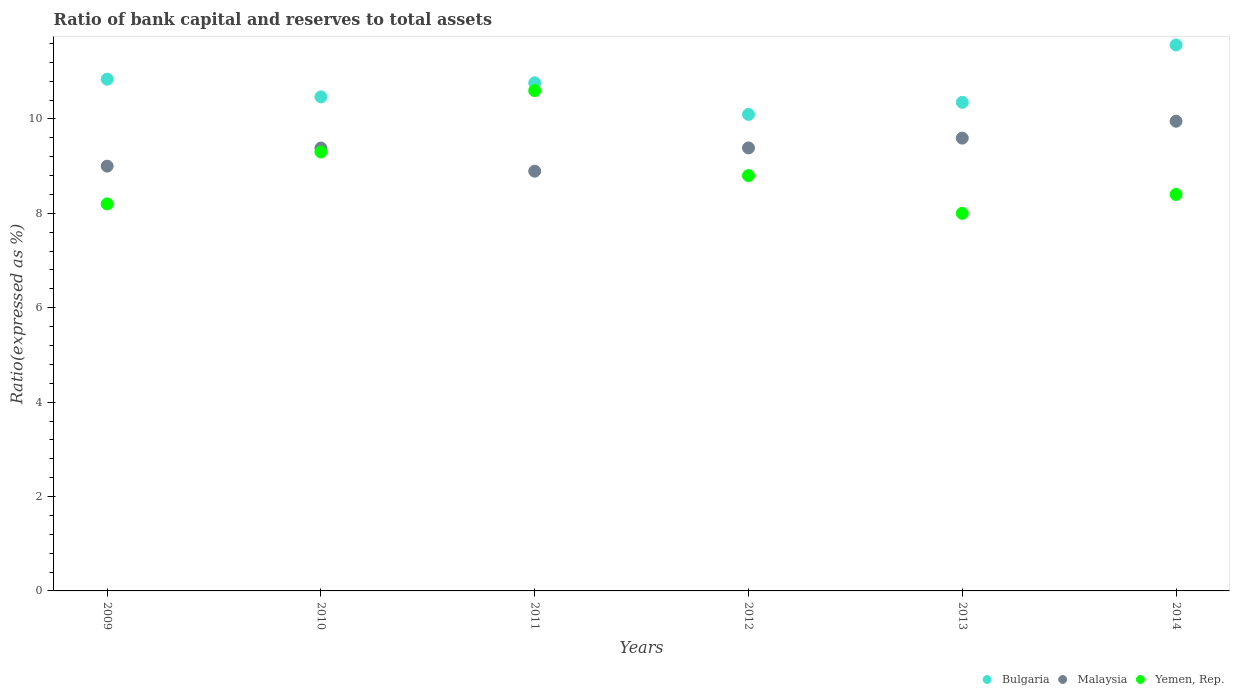What is the ratio of bank capital and reserves to total assets in Bulgaria in 2012?
Give a very brief answer. 10.1. Across all years, what is the maximum ratio of bank capital and reserves to total assets in Bulgaria?
Keep it short and to the point. 11.57. In which year was the ratio of bank capital and reserves to total assets in Yemen, Rep. maximum?
Offer a very short reply. 2011. What is the total ratio of bank capital and reserves to total assets in Bulgaria in the graph?
Provide a succinct answer. 64.09. What is the difference between the ratio of bank capital and reserves to total assets in Yemen, Rep. in 2011 and that in 2013?
Your answer should be compact. 2.6. What is the difference between the ratio of bank capital and reserves to total assets in Bulgaria in 2009 and the ratio of bank capital and reserves to total assets in Yemen, Rep. in 2012?
Provide a short and direct response. 2.04. What is the average ratio of bank capital and reserves to total assets in Malaysia per year?
Make the answer very short. 9.37. In the year 2009, what is the difference between the ratio of bank capital and reserves to total assets in Malaysia and ratio of bank capital and reserves to total assets in Bulgaria?
Provide a succinct answer. -1.84. Is the ratio of bank capital and reserves to total assets in Bulgaria in 2012 less than that in 2013?
Keep it short and to the point. Yes. What is the difference between the highest and the second highest ratio of bank capital and reserves to total assets in Bulgaria?
Your answer should be compact. 0.72. What is the difference between the highest and the lowest ratio of bank capital and reserves to total assets in Malaysia?
Your answer should be compact. 1.06. Is the sum of the ratio of bank capital and reserves to total assets in Yemen, Rep. in 2010 and 2011 greater than the maximum ratio of bank capital and reserves to total assets in Bulgaria across all years?
Provide a succinct answer. Yes. Is it the case that in every year, the sum of the ratio of bank capital and reserves to total assets in Bulgaria and ratio of bank capital and reserves to total assets in Yemen, Rep.  is greater than the ratio of bank capital and reserves to total assets in Malaysia?
Your answer should be compact. Yes. Does the ratio of bank capital and reserves to total assets in Yemen, Rep. monotonically increase over the years?
Your response must be concise. No. Is the ratio of bank capital and reserves to total assets in Bulgaria strictly less than the ratio of bank capital and reserves to total assets in Malaysia over the years?
Your answer should be very brief. No. How many dotlines are there?
Give a very brief answer. 3. Are the values on the major ticks of Y-axis written in scientific E-notation?
Make the answer very short. No. Does the graph contain any zero values?
Offer a terse response. No. How many legend labels are there?
Offer a terse response. 3. What is the title of the graph?
Make the answer very short. Ratio of bank capital and reserves to total assets. What is the label or title of the Y-axis?
Provide a short and direct response. Ratio(expressed as %). What is the Ratio(expressed as %) of Bulgaria in 2009?
Your answer should be compact. 10.84. What is the Ratio(expressed as %) of Yemen, Rep. in 2009?
Offer a terse response. 8.2. What is the Ratio(expressed as %) of Bulgaria in 2010?
Your answer should be very brief. 10.47. What is the Ratio(expressed as %) of Malaysia in 2010?
Make the answer very short. 9.38. What is the Ratio(expressed as %) in Yemen, Rep. in 2010?
Make the answer very short. 9.3. What is the Ratio(expressed as %) in Bulgaria in 2011?
Provide a succinct answer. 10.76. What is the Ratio(expressed as %) in Malaysia in 2011?
Make the answer very short. 8.89. What is the Ratio(expressed as %) in Yemen, Rep. in 2011?
Your answer should be compact. 10.6. What is the Ratio(expressed as %) in Bulgaria in 2012?
Offer a terse response. 10.1. What is the Ratio(expressed as %) of Malaysia in 2012?
Your answer should be very brief. 9.39. What is the Ratio(expressed as %) in Yemen, Rep. in 2012?
Offer a terse response. 8.8. What is the Ratio(expressed as %) of Bulgaria in 2013?
Ensure brevity in your answer.  10.35. What is the Ratio(expressed as %) in Malaysia in 2013?
Your answer should be compact. 9.59. What is the Ratio(expressed as %) of Yemen, Rep. in 2013?
Your response must be concise. 8. What is the Ratio(expressed as %) of Bulgaria in 2014?
Provide a succinct answer. 11.57. What is the Ratio(expressed as %) of Malaysia in 2014?
Give a very brief answer. 9.95. What is the Ratio(expressed as %) of Yemen, Rep. in 2014?
Give a very brief answer. 8.4. Across all years, what is the maximum Ratio(expressed as %) of Bulgaria?
Ensure brevity in your answer.  11.57. Across all years, what is the maximum Ratio(expressed as %) of Malaysia?
Offer a terse response. 9.95. Across all years, what is the minimum Ratio(expressed as %) in Bulgaria?
Keep it short and to the point. 10.1. Across all years, what is the minimum Ratio(expressed as %) of Malaysia?
Provide a succinct answer. 8.89. What is the total Ratio(expressed as %) in Bulgaria in the graph?
Provide a short and direct response. 64.09. What is the total Ratio(expressed as %) in Malaysia in the graph?
Your answer should be very brief. 56.21. What is the total Ratio(expressed as %) in Yemen, Rep. in the graph?
Provide a short and direct response. 53.3. What is the difference between the Ratio(expressed as %) in Bulgaria in 2009 and that in 2010?
Your response must be concise. 0.37. What is the difference between the Ratio(expressed as %) in Malaysia in 2009 and that in 2010?
Provide a succinct answer. -0.38. What is the difference between the Ratio(expressed as %) in Yemen, Rep. in 2009 and that in 2010?
Keep it short and to the point. -1.1. What is the difference between the Ratio(expressed as %) in Bulgaria in 2009 and that in 2011?
Offer a very short reply. 0.08. What is the difference between the Ratio(expressed as %) in Malaysia in 2009 and that in 2011?
Your response must be concise. 0.11. What is the difference between the Ratio(expressed as %) in Yemen, Rep. in 2009 and that in 2011?
Offer a very short reply. -2.4. What is the difference between the Ratio(expressed as %) of Bulgaria in 2009 and that in 2012?
Make the answer very short. 0.75. What is the difference between the Ratio(expressed as %) in Malaysia in 2009 and that in 2012?
Provide a succinct answer. -0.39. What is the difference between the Ratio(expressed as %) in Bulgaria in 2009 and that in 2013?
Give a very brief answer. 0.49. What is the difference between the Ratio(expressed as %) of Malaysia in 2009 and that in 2013?
Your response must be concise. -0.59. What is the difference between the Ratio(expressed as %) in Bulgaria in 2009 and that in 2014?
Your response must be concise. -0.72. What is the difference between the Ratio(expressed as %) in Malaysia in 2009 and that in 2014?
Provide a succinct answer. -0.95. What is the difference between the Ratio(expressed as %) of Yemen, Rep. in 2009 and that in 2014?
Provide a succinct answer. -0.2. What is the difference between the Ratio(expressed as %) of Bulgaria in 2010 and that in 2011?
Keep it short and to the point. -0.3. What is the difference between the Ratio(expressed as %) in Malaysia in 2010 and that in 2011?
Your response must be concise. 0.49. What is the difference between the Ratio(expressed as %) in Yemen, Rep. in 2010 and that in 2011?
Offer a terse response. -1.3. What is the difference between the Ratio(expressed as %) in Bulgaria in 2010 and that in 2012?
Your response must be concise. 0.37. What is the difference between the Ratio(expressed as %) in Malaysia in 2010 and that in 2012?
Your response must be concise. -0. What is the difference between the Ratio(expressed as %) in Bulgaria in 2010 and that in 2013?
Your answer should be very brief. 0.12. What is the difference between the Ratio(expressed as %) in Malaysia in 2010 and that in 2013?
Give a very brief answer. -0.21. What is the difference between the Ratio(expressed as %) in Yemen, Rep. in 2010 and that in 2013?
Your answer should be compact. 1.3. What is the difference between the Ratio(expressed as %) of Bulgaria in 2010 and that in 2014?
Ensure brevity in your answer.  -1.1. What is the difference between the Ratio(expressed as %) of Malaysia in 2010 and that in 2014?
Make the answer very short. -0.57. What is the difference between the Ratio(expressed as %) of Bulgaria in 2011 and that in 2012?
Provide a short and direct response. 0.67. What is the difference between the Ratio(expressed as %) of Malaysia in 2011 and that in 2012?
Provide a short and direct response. -0.49. What is the difference between the Ratio(expressed as %) in Yemen, Rep. in 2011 and that in 2012?
Your answer should be compact. 1.8. What is the difference between the Ratio(expressed as %) in Bulgaria in 2011 and that in 2013?
Ensure brevity in your answer.  0.41. What is the difference between the Ratio(expressed as %) in Malaysia in 2011 and that in 2013?
Offer a terse response. -0.7. What is the difference between the Ratio(expressed as %) of Yemen, Rep. in 2011 and that in 2013?
Keep it short and to the point. 2.6. What is the difference between the Ratio(expressed as %) of Bulgaria in 2011 and that in 2014?
Offer a very short reply. -0.8. What is the difference between the Ratio(expressed as %) in Malaysia in 2011 and that in 2014?
Keep it short and to the point. -1.06. What is the difference between the Ratio(expressed as %) in Yemen, Rep. in 2011 and that in 2014?
Provide a short and direct response. 2.2. What is the difference between the Ratio(expressed as %) of Bulgaria in 2012 and that in 2013?
Your response must be concise. -0.26. What is the difference between the Ratio(expressed as %) in Malaysia in 2012 and that in 2013?
Keep it short and to the point. -0.21. What is the difference between the Ratio(expressed as %) in Yemen, Rep. in 2012 and that in 2013?
Your response must be concise. 0.8. What is the difference between the Ratio(expressed as %) of Bulgaria in 2012 and that in 2014?
Make the answer very short. -1.47. What is the difference between the Ratio(expressed as %) of Malaysia in 2012 and that in 2014?
Offer a terse response. -0.57. What is the difference between the Ratio(expressed as %) of Bulgaria in 2013 and that in 2014?
Your response must be concise. -1.22. What is the difference between the Ratio(expressed as %) of Malaysia in 2013 and that in 2014?
Your answer should be very brief. -0.36. What is the difference between the Ratio(expressed as %) in Bulgaria in 2009 and the Ratio(expressed as %) in Malaysia in 2010?
Offer a terse response. 1.46. What is the difference between the Ratio(expressed as %) in Bulgaria in 2009 and the Ratio(expressed as %) in Yemen, Rep. in 2010?
Make the answer very short. 1.54. What is the difference between the Ratio(expressed as %) of Bulgaria in 2009 and the Ratio(expressed as %) of Malaysia in 2011?
Your answer should be very brief. 1.95. What is the difference between the Ratio(expressed as %) in Bulgaria in 2009 and the Ratio(expressed as %) in Yemen, Rep. in 2011?
Offer a very short reply. 0.24. What is the difference between the Ratio(expressed as %) in Bulgaria in 2009 and the Ratio(expressed as %) in Malaysia in 2012?
Offer a very short reply. 1.46. What is the difference between the Ratio(expressed as %) of Bulgaria in 2009 and the Ratio(expressed as %) of Yemen, Rep. in 2012?
Ensure brevity in your answer.  2.04. What is the difference between the Ratio(expressed as %) of Malaysia in 2009 and the Ratio(expressed as %) of Yemen, Rep. in 2012?
Ensure brevity in your answer.  0.2. What is the difference between the Ratio(expressed as %) of Bulgaria in 2009 and the Ratio(expressed as %) of Malaysia in 2013?
Ensure brevity in your answer.  1.25. What is the difference between the Ratio(expressed as %) in Bulgaria in 2009 and the Ratio(expressed as %) in Yemen, Rep. in 2013?
Your answer should be compact. 2.84. What is the difference between the Ratio(expressed as %) in Malaysia in 2009 and the Ratio(expressed as %) in Yemen, Rep. in 2013?
Provide a succinct answer. 1. What is the difference between the Ratio(expressed as %) of Bulgaria in 2009 and the Ratio(expressed as %) of Malaysia in 2014?
Offer a very short reply. 0.89. What is the difference between the Ratio(expressed as %) in Bulgaria in 2009 and the Ratio(expressed as %) in Yemen, Rep. in 2014?
Offer a terse response. 2.44. What is the difference between the Ratio(expressed as %) of Malaysia in 2009 and the Ratio(expressed as %) of Yemen, Rep. in 2014?
Make the answer very short. 0.6. What is the difference between the Ratio(expressed as %) of Bulgaria in 2010 and the Ratio(expressed as %) of Malaysia in 2011?
Provide a short and direct response. 1.57. What is the difference between the Ratio(expressed as %) of Bulgaria in 2010 and the Ratio(expressed as %) of Yemen, Rep. in 2011?
Your response must be concise. -0.13. What is the difference between the Ratio(expressed as %) of Malaysia in 2010 and the Ratio(expressed as %) of Yemen, Rep. in 2011?
Provide a short and direct response. -1.22. What is the difference between the Ratio(expressed as %) in Bulgaria in 2010 and the Ratio(expressed as %) in Malaysia in 2012?
Your response must be concise. 1.08. What is the difference between the Ratio(expressed as %) in Bulgaria in 2010 and the Ratio(expressed as %) in Yemen, Rep. in 2012?
Offer a terse response. 1.67. What is the difference between the Ratio(expressed as %) of Malaysia in 2010 and the Ratio(expressed as %) of Yemen, Rep. in 2012?
Offer a terse response. 0.58. What is the difference between the Ratio(expressed as %) in Bulgaria in 2010 and the Ratio(expressed as %) in Malaysia in 2013?
Your answer should be compact. 0.87. What is the difference between the Ratio(expressed as %) of Bulgaria in 2010 and the Ratio(expressed as %) of Yemen, Rep. in 2013?
Provide a short and direct response. 2.47. What is the difference between the Ratio(expressed as %) in Malaysia in 2010 and the Ratio(expressed as %) in Yemen, Rep. in 2013?
Keep it short and to the point. 1.38. What is the difference between the Ratio(expressed as %) in Bulgaria in 2010 and the Ratio(expressed as %) in Malaysia in 2014?
Make the answer very short. 0.52. What is the difference between the Ratio(expressed as %) of Bulgaria in 2010 and the Ratio(expressed as %) of Yemen, Rep. in 2014?
Provide a short and direct response. 2.07. What is the difference between the Ratio(expressed as %) in Malaysia in 2010 and the Ratio(expressed as %) in Yemen, Rep. in 2014?
Your response must be concise. 0.98. What is the difference between the Ratio(expressed as %) of Bulgaria in 2011 and the Ratio(expressed as %) of Malaysia in 2012?
Provide a succinct answer. 1.38. What is the difference between the Ratio(expressed as %) of Bulgaria in 2011 and the Ratio(expressed as %) of Yemen, Rep. in 2012?
Offer a very short reply. 1.96. What is the difference between the Ratio(expressed as %) of Malaysia in 2011 and the Ratio(expressed as %) of Yemen, Rep. in 2012?
Your answer should be very brief. 0.09. What is the difference between the Ratio(expressed as %) of Bulgaria in 2011 and the Ratio(expressed as %) of Malaysia in 2013?
Give a very brief answer. 1.17. What is the difference between the Ratio(expressed as %) of Bulgaria in 2011 and the Ratio(expressed as %) of Yemen, Rep. in 2013?
Make the answer very short. 2.76. What is the difference between the Ratio(expressed as %) in Malaysia in 2011 and the Ratio(expressed as %) in Yemen, Rep. in 2013?
Make the answer very short. 0.89. What is the difference between the Ratio(expressed as %) in Bulgaria in 2011 and the Ratio(expressed as %) in Malaysia in 2014?
Make the answer very short. 0.81. What is the difference between the Ratio(expressed as %) in Bulgaria in 2011 and the Ratio(expressed as %) in Yemen, Rep. in 2014?
Your response must be concise. 2.36. What is the difference between the Ratio(expressed as %) in Malaysia in 2011 and the Ratio(expressed as %) in Yemen, Rep. in 2014?
Provide a succinct answer. 0.49. What is the difference between the Ratio(expressed as %) in Bulgaria in 2012 and the Ratio(expressed as %) in Malaysia in 2013?
Make the answer very short. 0.5. What is the difference between the Ratio(expressed as %) in Bulgaria in 2012 and the Ratio(expressed as %) in Yemen, Rep. in 2013?
Ensure brevity in your answer.  2.1. What is the difference between the Ratio(expressed as %) of Malaysia in 2012 and the Ratio(expressed as %) of Yemen, Rep. in 2013?
Provide a short and direct response. 1.39. What is the difference between the Ratio(expressed as %) of Bulgaria in 2012 and the Ratio(expressed as %) of Malaysia in 2014?
Your answer should be compact. 0.14. What is the difference between the Ratio(expressed as %) in Bulgaria in 2012 and the Ratio(expressed as %) in Yemen, Rep. in 2014?
Give a very brief answer. 1.7. What is the difference between the Ratio(expressed as %) of Malaysia in 2012 and the Ratio(expressed as %) of Yemen, Rep. in 2014?
Make the answer very short. 0.99. What is the difference between the Ratio(expressed as %) of Bulgaria in 2013 and the Ratio(expressed as %) of Malaysia in 2014?
Keep it short and to the point. 0.4. What is the difference between the Ratio(expressed as %) of Bulgaria in 2013 and the Ratio(expressed as %) of Yemen, Rep. in 2014?
Your answer should be very brief. 1.95. What is the difference between the Ratio(expressed as %) of Malaysia in 2013 and the Ratio(expressed as %) of Yemen, Rep. in 2014?
Offer a terse response. 1.19. What is the average Ratio(expressed as %) in Bulgaria per year?
Make the answer very short. 10.68. What is the average Ratio(expressed as %) of Malaysia per year?
Offer a very short reply. 9.37. What is the average Ratio(expressed as %) in Yemen, Rep. per year?
Your response must be concise. 8.88. In the year 2009, what is the difference between the Ratio(expressed as %) of Bulgaria and Ratio(expressed as %) of Malaysia?
Make the answer very short. 1.84. In the year 2009, what is the difference between the Ratio(expressed as %) in Bulgaria and Ratio(expressed as %) in Yemen, Rep.?
Offer a terse response. 2.64. In the year 2009, what is the difference between the Ratio(expressed as %) of Malaysia and Ratio(expressed as %) of Yemen, Rep.?
Your answer should be compact. 0.8. In the year 2010, what is the difference between the Ratio(expressed as %) of Bulgaria and Ratio(expressed as %) of Malaysia?
Your response must be concise. 1.08. In the year 2010, what is the difference between the Ratio(expressed as %) in Bulgaria and Ratio(expressed as %) in Yemen, Rep.?
Offer a very short reply. 1.17. In the year 2010, what is the difference between the Ratio(expressed as %) of Malaysia and Ratio(expressed as %) of Yemen, Rep.?
Give a very brief answer. 0.08. In the year 2011, what is the difference between the Ratio(expressed as %) of Bulgaria and Ratio(expressed as %) of Malaysia?
Offer a terse response. 1.87. In the year 2011, what is the difference between the Ratio(expressed as %) in Bulgaria and Ratio(expressed as %) in Yemen, Rep.?
Your answer should be compact. 0.16. In the year 2011, what is the difference between the Ratio(expressed as %) in Malaysia and Ratio(expressed as %) in Yemen, Rep.?
Make the answer very short. -1.71. In the year 2012, what is the difference between the Ratio(expressed as %) of Bulgaria and Ratio(expressed as %) of Malaysia?
Your answer should be compact. 0.71. In the year 2012, what is the difference between the Ratio(expressed as %) in Bulgaria and Ratio(expressed as %) in Yemen, Rep.?
Offer a very short reply. 1.3. In the year 2012, what is the difference between the Ratio(expressed as %) of Malaysia and Ratio(expressed as %) of Yemen, Rep.?
Provide a succinct answer. 0.59. In the year 2013, what is the difference between the Ratio(expressed as %) of Bulgaria and Ratio(expressed as %) of Malaysia?
Your answer should be compact. 0.76. In the year 2013, what is the difference between the Ratio(expressed as %) of Bulgaria and Ratio(expressed as %) of Yemen, Rep.?
Offer a very short reply. 2.35. In the year 2013, what is the difference between the Ratio(expressed as %) of Malaysia and Ratio(expressed as %) of Yemen, Rep.?
Your answer should be compact. 1.59. In the year 2014, what is the difference between the Ratio(expressed as %) in Bulgaria and Ratio(expressed as %) in Malaysia?
Give a very brief answer. 1.62. In the year 2014, what is the difference between the Ratio(expressed as %) in Bulgaria and Ratio(expressed as %) in Yemen, Rep.?
Provide a short and direct response. 3.17. In the year 2014, what is the difference between the Ratio(expressed as %) in Malaysia and Ratio(expressed as %) in Yemen, Rep.?
Your response must be concise. 1.55. What is the ratio of the Ratio(expressed as %) of Bulgaria in 2009 to that in 2010?
Provide a succinct answer. 1.04. What is the ratio of the Ratio(expressed as %) of Malaysia in 2009 to that in 2010?
Give a very brief answer. 0.96. What is the ratio of the Ratio(expressed as %) in Yemen, Rep. in 2009 to that in 2010?
Provide a succinct answer. 0.88. What is the ratio of the Ratio(expressed as %) in Bulgaria in 2009 to that in 2011?
Your answer should be very brief. 1.01. What is the ratio of the Ratio(expressed as %) of Malaysia in 2009 to that in 2011?
Your answer should be very brief. 1.01. What is the ratio of the Ratio(expressed as %) of Yemen, Rep. in 2009 to that in 2011?
Offer a very short reply. 0.77. What is the ratio of the Ratio(expressed as %) in Bulgaria in 2009 to that in 2012?
Give a very brief answer. 1.07. What is the ratio of the Ratio(expressed as %) in Malaysia in 2009 to that in 2012?
Your answer should be compact. 0.96. What is the ratio of the Ratio(expressed as %) of Yemen, Rep. in 2009 to that in 2012?
Offer a very short reply. 0.93. What is the ratio of the Ratio(expressed as %) in Bulgaria in 2009 to that in 2013?
Your answer should be compact. 1.05. What is the ratio of the Ratio(expressed as %) of Malaysia in 2009 to that in 2013?
Make the answer very short. 0.94. What is the ratio of the Ratio(expressed as %) in Bulgaria in 2009 to that in 2014?
Offer a terse response. 0.94. What is the ratio of the Ratio(expressed as %) in Malaysia in 2009 to that in 2014?
Make the answer very short. 0.9. What is the ratio of the Ratio(expressed as %) in Yemen, Rep. in 2009 to that in 2014?
Your answer should be very brief. 0.98. What is the ratio of the Ratio(expressed as %) in Bulgaria in 2010 to that in 2011?
Your answer should be very brief. 0.97. What is the ratio of the Ratio(expressed as %) of Malaysia in 2010 to that in 2011?
Provide a succinct answer. 1.06. What is the ratio of the Ratio(expressed as %) of Yemen, Rep. in 2010 to that in 2011?
Offer a terse response. 0.88. What is the ratio of the Ratio(expressed as %) in Bulgaria in 2010 to that in 2012?
Your answer should be very brief. 1.04. What is the ratio of the Ratio(expressed as %) of Yemen, Rep. in 2010 to that in 2012?
Your answer should be compact. 1.06. What is the ratio of the Ratio(expressed as %) of Bulgaria in 2010 to that in 2013?
Offer a very short reply. 1.01. What is the ratio of the Ratio(expressed as %) of Malaysia in 2010 to that in 2013?
Make the answer very short. 0.98. What is the ratio of the Ratio(expressed as %) of Yemen, Rep. in 2010 to that in 2013?
Provide a succinct answer. 1.16. What is the ratio of the Ratio(expressed as %) in Bulgaria in 2010 to that in 2014?
Ensure brevity in your answer.  0.91. What is the ratio of the Ratio(expressed as %) in Malaysia in 2010 to that in 2014?
Make the answer very short. 0.94. What is the ratio of the Ratio(expressed as %) in Yemen, Rep. in 2010 to that in 2014?
Give a very brief answer. 1.11. What is the ratio of the Ratio(expressed as %) of Bulgaria in 2011 to that in 2012?
Your response must be concise. 1.07. What is the ratio of the Ratio(expressed as %) of Malaysia in 2011 to that in 2012?
Give a very brief answer. 0.95. What is the ratio of the Ratio(expressed as %) of Yemen, Rep. in 2011 to that in 2012?
Make the answer very short. 1.2. What is the ratio of the Ratio(expressed as %) in Bulgaria in 2011 to that in 2013?
Offer a terse response. 1.04. What is the ratio of the Ratio(expressed as %) in Malaysia in 2011 to that in 2013?
Your answer should be very brief. 0.93. What is the ratio of the Ratio(expressed as %) of Yemen, Rep. in 2011 to that in 2013?
Offer a terse response. 1.32. What is the ratio of the Ratio(expressed as %) in Bulgaria in 2011 to that in 2014?
Your response must be concise. 0.93. What is the ratio of the Ratio(expressed as %) in Malaysia in 2011 to that in 2014?
Provide a succinct answer. 0.89. What is the ratio of the Ratio(expressed as %) in Yemen, Rep. in 2011 to that in 2014?
Keep it short and to the point. 1.26. What is the ratio of the Ratio(expressed as %) in Bulgaria in 2012 to that in 2013?
Ensure brevity in your answer.  0.98. What is the ratio of the Ratio(expressed as %) of Malaysia in 2012 to that in 2013?
Your response must be concise. 0.98. What is the ratio of the Ratio(expressed as %) in Yemen, Rep. in 2012 to that in 2013?
Your answer should be compact. 1.1. What is the ratio of the Ratio(expressed as %) of Bulgaria in 2012 to that in 2014?
Offer a very short reply. 0.87. What is the ratio of the Ratio(expressed as %) in Malaysia in 2012 to that in 2014?
Your response must be concise. 0.94. What is the ratio of the Ratio(expressed as %) in Yemen, Rep. in 2012 to that in 2014?
Provide a succinct answer. 1.05. What is the ratio of the Ratio(expressed as %) of Bulgaria in 2013 to that in 2014?
Give a very brief answer. 0.89. What is the ratio of the Ratio(expressed as %) of Malaysia in 2013 to that in 2014?
Ensure brevity in your answer.  0.96. What is the ratio of the Ratio(expressed as %) in Yemen, Rep. in 2013 to that in 2014?
Your answer should be very brief. 0.95. What is the difference between the highest and the second highest Ratio(expressed as %) in Bulgaria?
Your answer should be very brief. 0.72. What is the difference between the highest and the second highest Ratio(expressed as %) in Malaysia?
Provide a short and direct response. 0.36. What is the difference between the highest and the second highest Ratio(expressed as %) of Yemen, Rep.?
Make the answer very short. 1.3. What is the difference between the highest and the lowest Ratio(expressed as %) of Bulgaria?
Offer a terse response. 1.47. What is the difference between the highest and the lowest Ratio(expressed as %) in Malaysia?
Your answer should be compact. 1.06. 